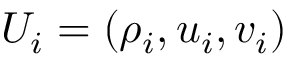<formula> <loc_0><loc_0><loc_500><loc_500>U _ { i } = ( \rho _ { i } , u _ { i } , v _ { i } )</formula> 